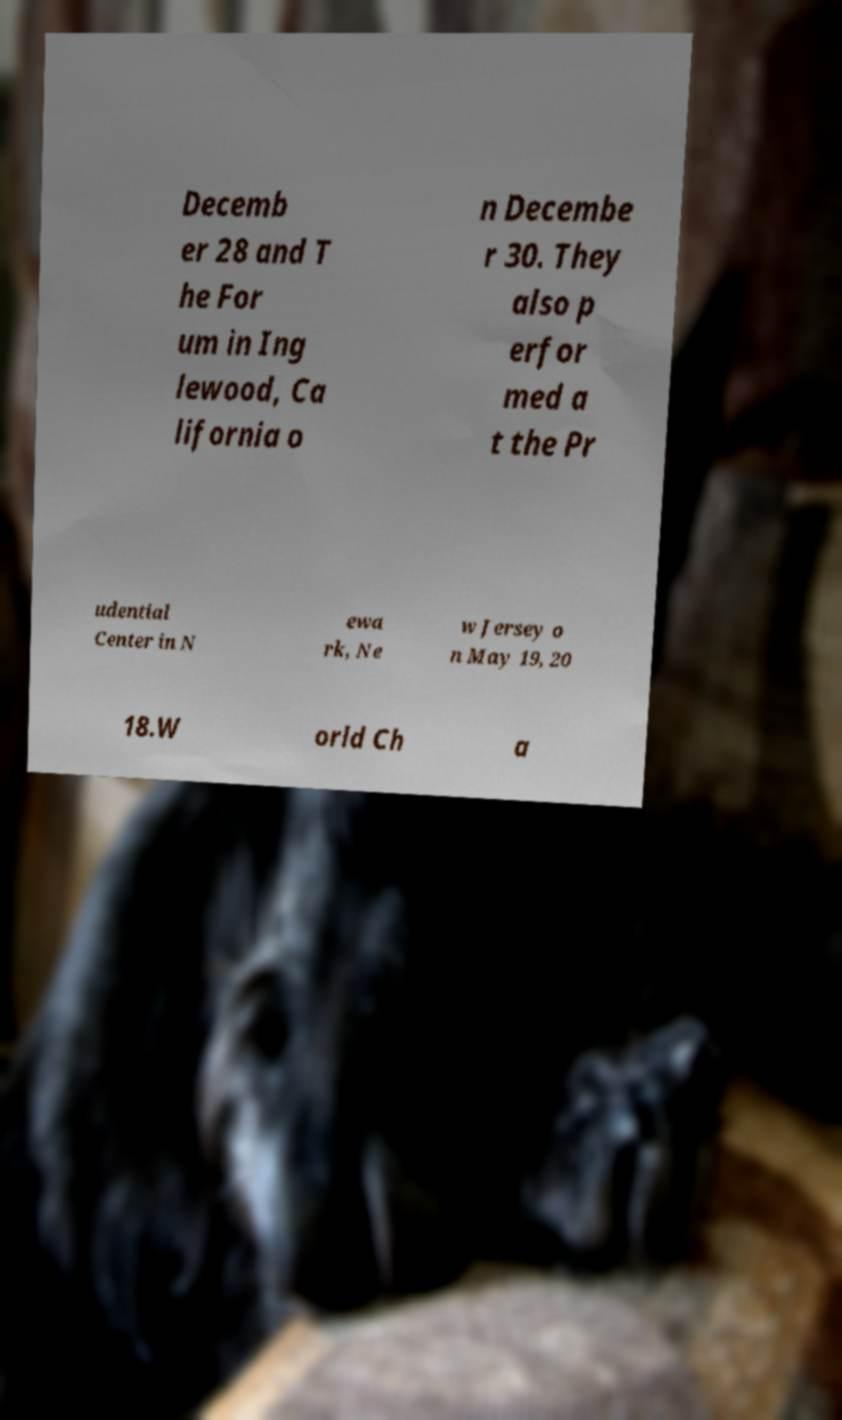What messages or text are displayed in this image? I need them in a readable, typed format. Decemb er 28 and T he For um in Ing lewood, Ca lifornia o n Decembe r 30. They also p erfor med a t the Pr udential Center in N ewa rk, Ne w Jersey o n May 19, 20 18.W orld Ch a 